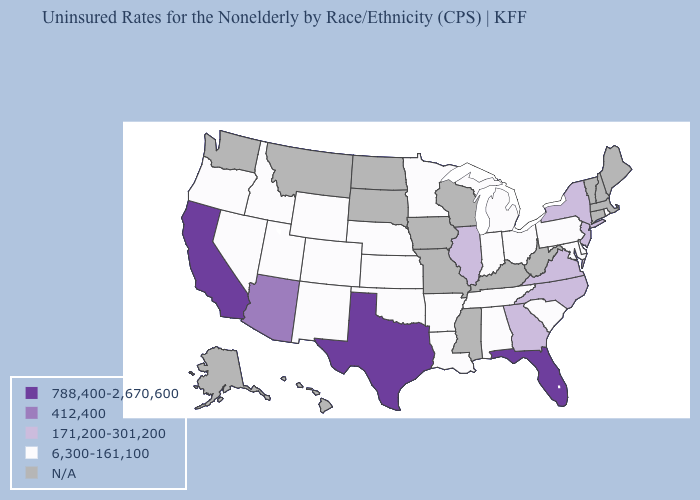What is the value of Colorado?
Keep it brief. 6,300-161,100. What is the value of Tennessee?
Answer briefly. 6,300-161,100. Name the states that have a value in the range N/A?
Concise answer only. Alaska, Connecticut, Hawaii, Iowa, Kentucky, Maine, Massachusetts, Mississippi, Missouri, Montana, New Hampshire, North Dakota, South Dakota, Vermont, Washington, West Virginia, Wisconsin. Is the legend a continuous bar?
Concise answer only. No. Name the states that have a value in the range N/A?
Keep it brief. Alaska, Connecticut, Hawaii, Iowa, Kentucky, Maine, Massachusetts, Mississippi, Missouri, Montana, New Hampshire, North Dakota, South Dakota, Vermont, Washington, West Virginia, Wisconsin. Name the states that have a value in the range 171,200-301,200?
Concise answer only. Georgia, Illinois, New Jersey, New York, North Carolina, Virginia. Among the states that border Kansas , which have the highest value?
Short answer required. Colorado, Nebraska, Oklahoma. What is the value of Georgia?
Answer briefly. 171,200-301,200. What is the value of Missouri?
Concise answer only. N/A. Which states have the lowest value in the Northeast?
Give a very brief answer. Pennsylvania, Rhode Island. What is the value of Washington?
Keep it brief. N/A. 